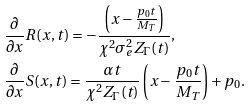<formula> <loc_0><loc_0><loc_500><loc_500>& \frac { \partial } { \partial x } R ( x , t ) = - \frac { \left ( x - \frac { p _ { 0 } t } { M _ { T } } \right ) } { \chi ^ { 2 } \sigma ^ { 2 } _ { e } Z _ { \Gamma } ( t ) } , \\ & \frac { \partial } { \partial x } S ( x , t ) = \frac { \alpha t } { \chi ^ { 2 } Z _ { \Gamma } ( t ) } \left ( x - \frac { p _ { 0 } t } { M _ { T } } \right ) + p _ { 0 } .</formula> 